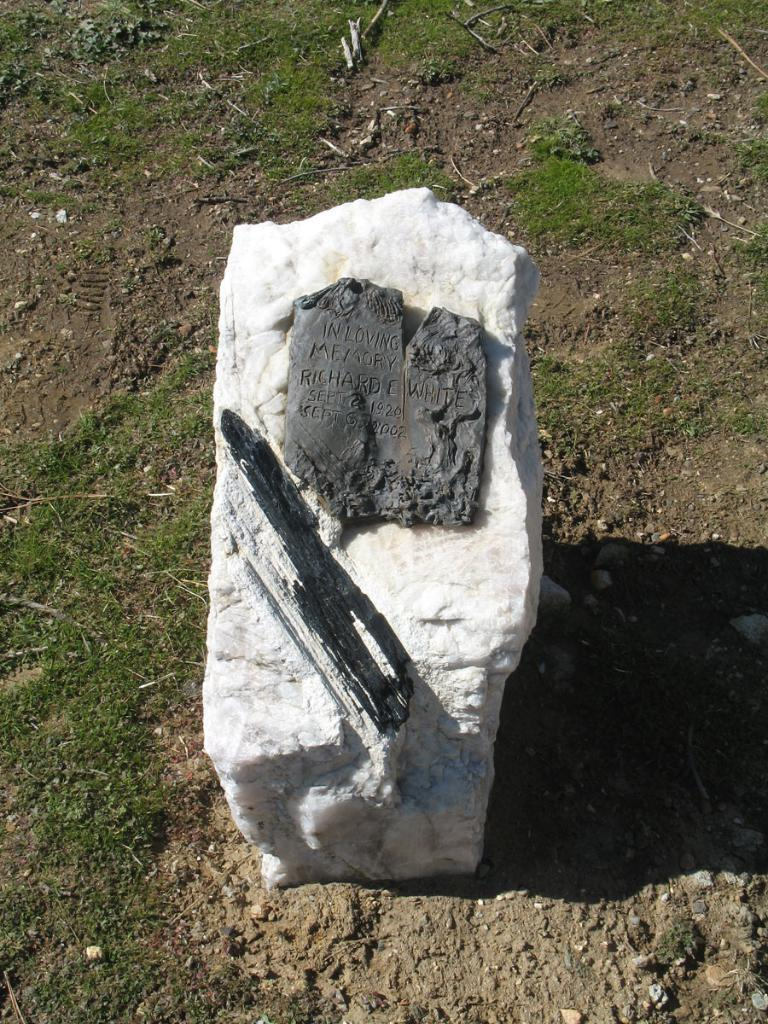What object is on the ground in the image? There is a stone on the ground in the image. What is written or depicted on the stone? There is some text on the stone. What type of vegetation is visible in the image? There is grass visible in the image. How many wings can be seen on the stone in the image? There are no wings present on the stone in the image. What type of bird is depicted on the stone in the image? There is no bird, including a turkey, depicted on the stone in the image. 